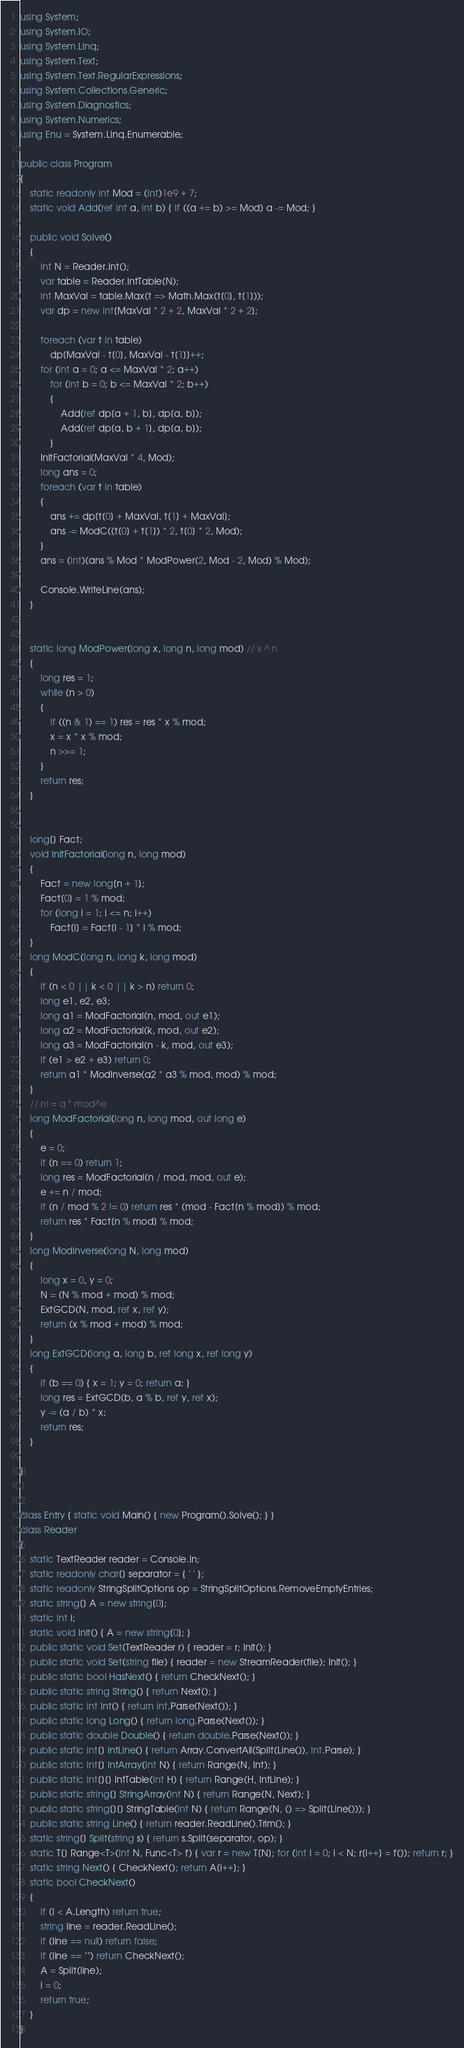Convert code to text. <code><loc_0><loc_0><loc_500><loc_500><_C#_>using System;
using System.IO;
using System.Linq;
using System.Text;
using System.Text.RegularExpressions;
using System.Collections.Generic;
using System.Diagnostics;
using System.Numerics;
using Enu = System.Linq.Enumerable;

public class Program
{
    static readonly int Mod = (int)1e9 + 7;
    static void Add(ref int a, int b) { if ((a += b) >= Mod) a -= Mod; }

    public void Solve()
    {
        int N = Reader.Int();
        var table = Reader.IntTable(N);
        int MaxVal = table.Max(t => Math.Max(t[0], t[1]));
        var dp = new int[MaxVal * 2 + 2, MaxVal * 2 + 2];

        foreach (var t in table)
            dp[MaxVal - t[0], MaxVal - t[1]]++;
        for (int a = 0; a <= MaxVal * 2; a++)
            for (int b = 0; b <= MaxVal * 2; b++)
            {
                Add(ref dp[a + 1, b], dp[a, b]);
                Add(ref dp[a, b + 1], dp[a, b]);
            }
        InitFactorial(MaxVal * 4, Mod);
        long ans = 0;
        foreach (var t in table)
        {
            ans += dp[t[0] + MaxVal, t[1] + MaxVal];
            ans -= ModC((t[0] + t[1]) * 2, t[0] * 2, Mod);
        }
        ans = (int)(ans % Mod * ModPower(2, Mod - 2, Mod) % Mod);

        Console.WriteLine(ans);
    }


    static long ModPower(long x, long n, long mod) // x ^ n
    {
        long res = 1;
        while (n > 0)
        {
            if ((n & 1) == 1) res = res * x % mod;
            x = x * x % mod;
            n >>= 1;
        }
        return res;
    }


    long[] Fact;
    void InitFactorial(long n, long mod)
    {
        Fact = new long[n + 1];
        Fact[0] = 1 % mod;
        for (long i = 1; i <= n; i++)
            Fact[i] = Fact[i - 1] * i % mod;
    }
    long ModC(long n, long k, long mod)
    {
        if (n < 0 || k < 0 || k > n) return 0;
        long e1, e2, e3;
        long a1 = ModFactorial(n, mod, out e1);
        long a2 = ModFactorial(k, mod, out e2);
        long a3 = ModFactorial(n - k, mod, out e3);
        if (e1 > e2 + e3) return 0;
        return a1 * ModInverse(a2 * a3 % mod, mod) % mod;
    }
    // n! = a * mod^e
    long ModFactorial(long n, long mod, out long e)
    {
        e = 0;
        if (n == 0) return 1;
        long res = ModFactorial(n / mod, mod, out e);
        e += n / mod;
        if (n / mod % 2 != 0) return res * (mod - Fact[n % mod]) % mod;
        return res * Fact[n % mod] % mod;
    }
    long ModInverse(long N, long mod)
    {
        long x = 0, y = 0;
        N = (N % mod + mod) % mod;
        ExtGCD(N, mod, ref x, ref y);
        return (x % mod + mod) % mod;
    }
    long ExtGCD(long a, long b, ref long x, ref long y)
    {
        if (b == 0) { x = 1; y = 0; return a; }
        long res = ExtGCD(b, a % b, ref y, ref x);
        y -= (a / b) * x;
        return res;
    }

}


class Entry { static void Main() { new Program().Solve(); } }
class Reader
{
    static TextReader reader = Console.In;
    static readonly char[] separator = { ' ' };
    static readonly StringSplitOptions op = StringSplitOptions.RemoveEmptyEntries;
    static string[] A = new string[0];
    static int i;
    static void Init() { A = new string[0]; }
    public static void Set(TextReader r) { reader = r; Init(); }
    public static void Set(string file) { reader = new StreamReader(file); Init(); }
    public static bool HasNext() { return CheckNext(); }
    public static string String() { return Next(); }
    public static int Int() { return int.Parse(Next()); }
    public static long Long() { return long.Parse(Next()); }
    public static double Double() { return double.Parse(Next()); }
    public static int[] IntLine() { return Array.ConvertAll(Split(Line()), int.Parse); }
    public static int[] IntArray(int N) { return Range(N, Int); }
    public static int[][] IntTable(int H) { return Range(H, IntLine); }
    public static string[] StringArray(int N) { return Range(N, Next); }
    public static string[][] StringTable(int N) { return Range(N, () => Split(Line())); }
    public static string Line() { return reader.ReadLine().Trim(); }
    static string[] Split(string s) { return s.Split(separator, op); }
    static T[] Range<T>(int N, Func<T> f) { var r = new T[N]; for (int i = 0; i < N; r[i++] = f()); return r; }
    static string Next() { CheckNext(); return A[i++]; }
    static bool CheckNext()
    {
        if (i < A.Length) return true;
        string line = reader.ReadLine();
        if (line == null) return false;
        if (line == "") return CheckNext();
        A = Split(line);
        i = 0;
        return true;
    }
}
</code> 